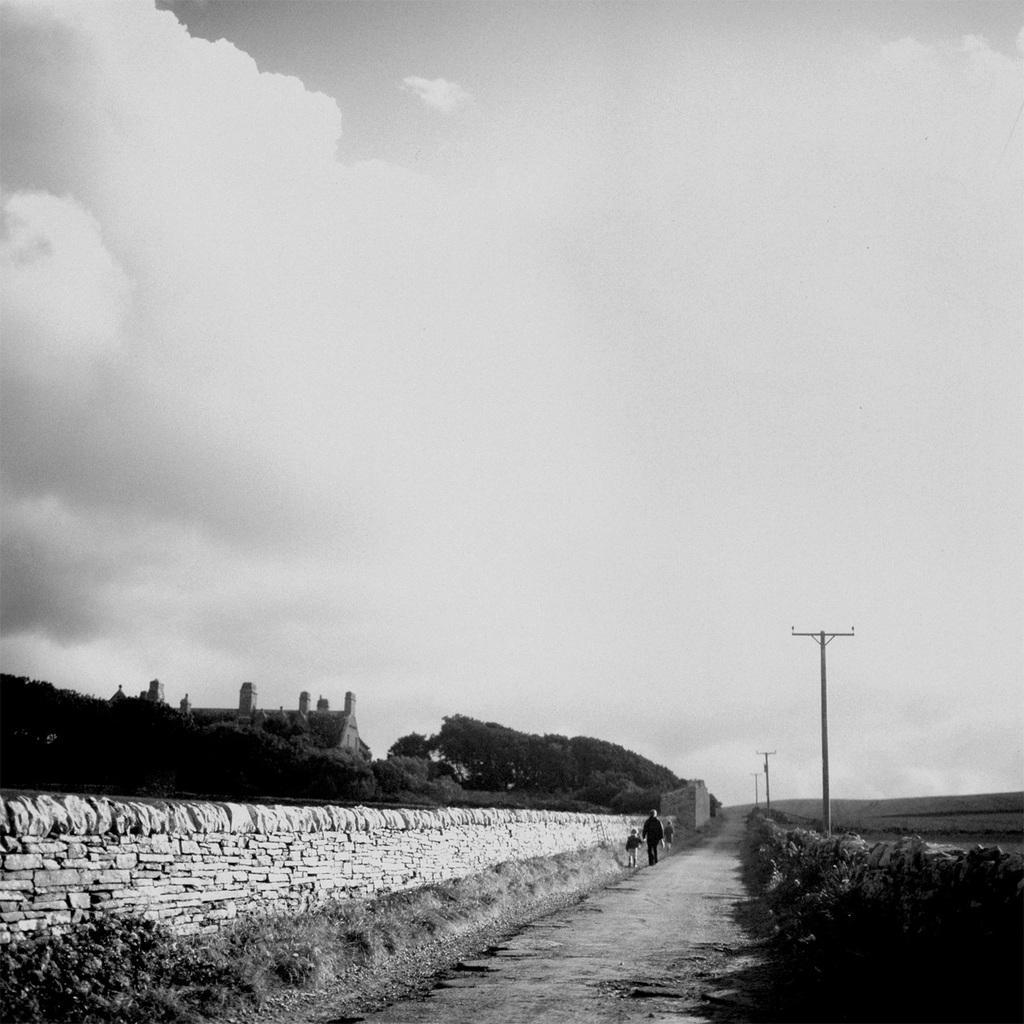In one or two sentences, can you explain what this image depicts? This is a black and white image. At the bottom there are few people walking on the road. On both sides of the road there are few plants. On the left side there is a wall. On the right side there are few poles. In the background there are few trees and a building. At the top of the image I can see the sky and clouds. 